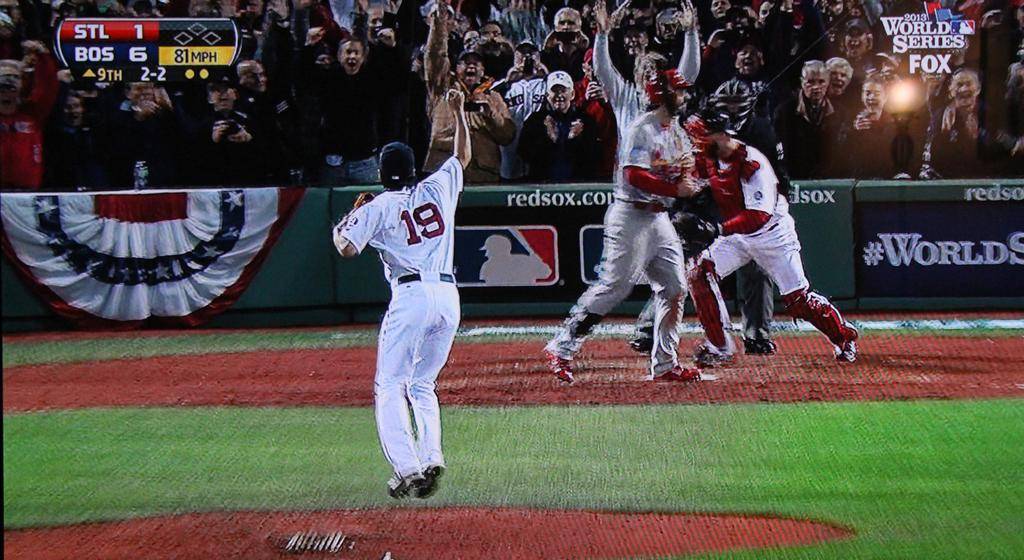<image>
Relay a brief, clear account of the picture shown. The pitcher no. 19 jumps to celebrate as the batter walks away from the plate. 